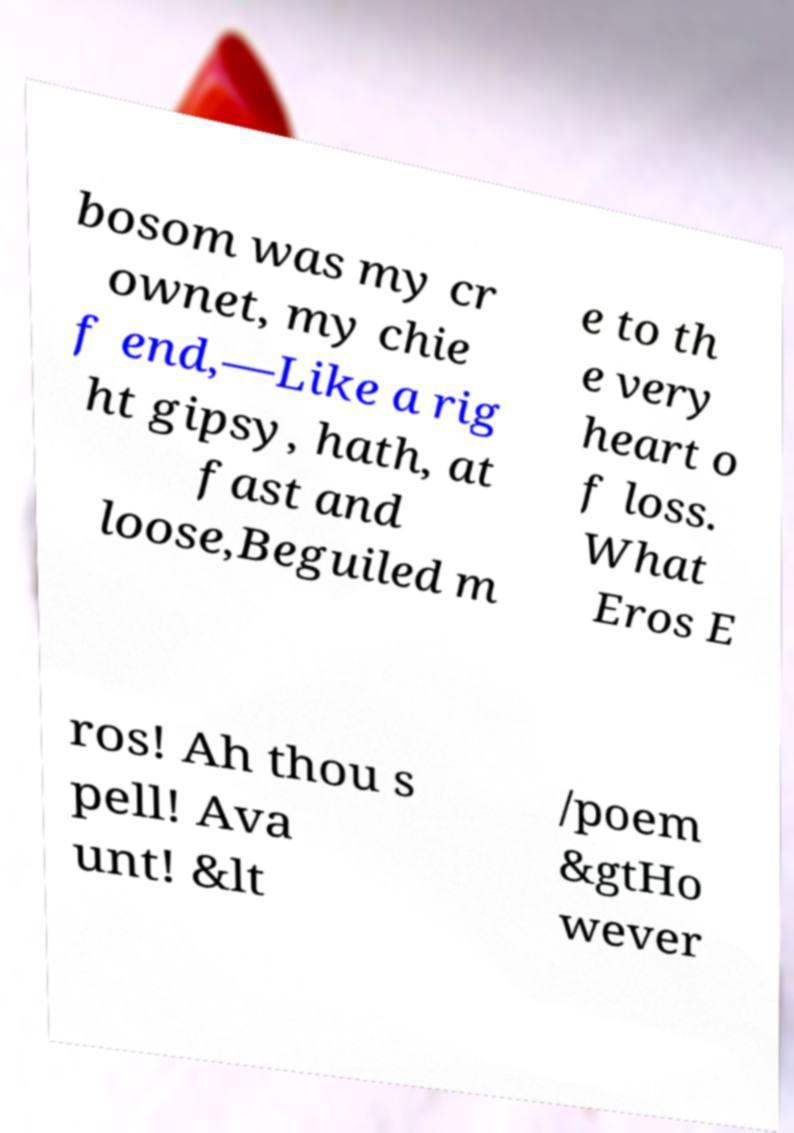Could you assist in decoding the text presented in this image and type it out clearly? bosom was my cr ownet, my chie f end,—Like a rig ht gipsy, hath, at fast and loose,Beguiled m e to th e very heart o f loss. What Eros E ros! Ah thou s pell! Ava unt! &lt /poem &gtHo wever 